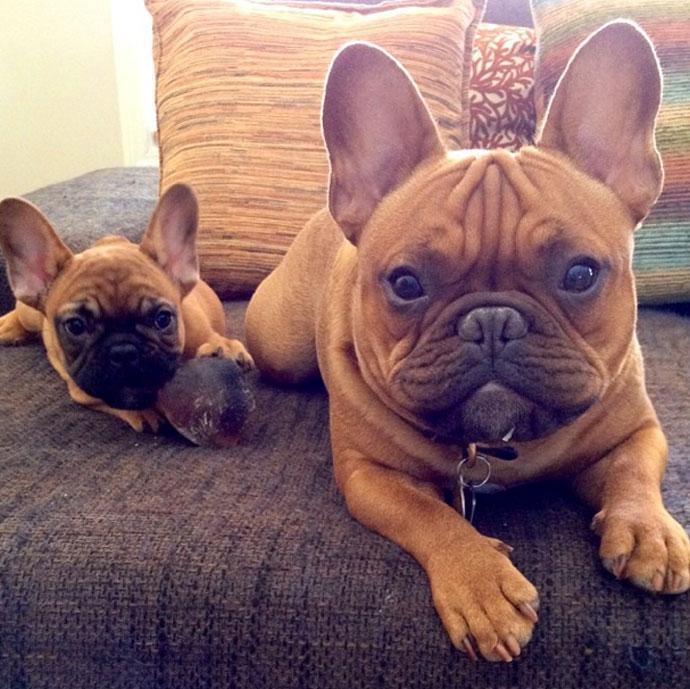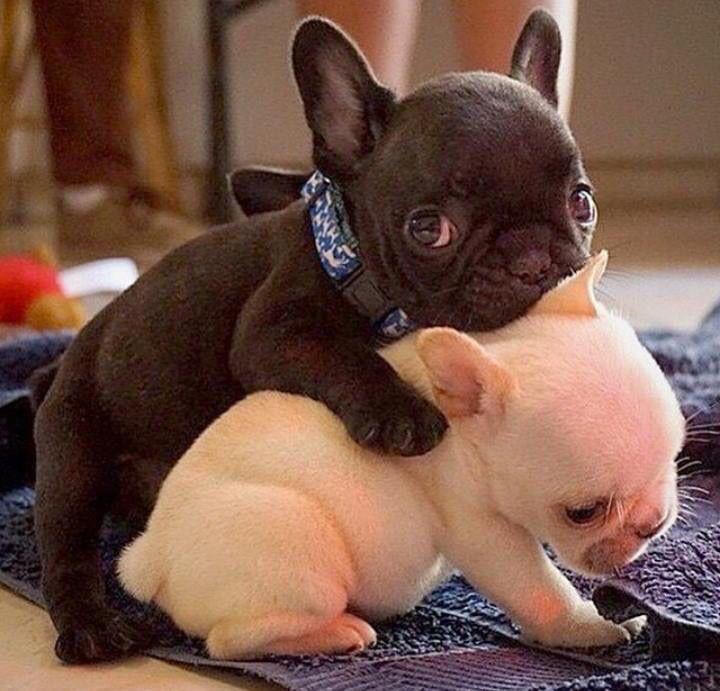The first image is the image on the left, the second image is the image on the right. Examine the images to the left and right. Is the description "An image contains one black puppy with its front paws around one white puppy." accurate? Answer yes or no. Yes. The first image is the image on the left, the second image is the image on the right. Considering the images on both sides, is "There is at least one black french bulldog that is hugging a white dog." valid? Answer yes or no. Yes. 